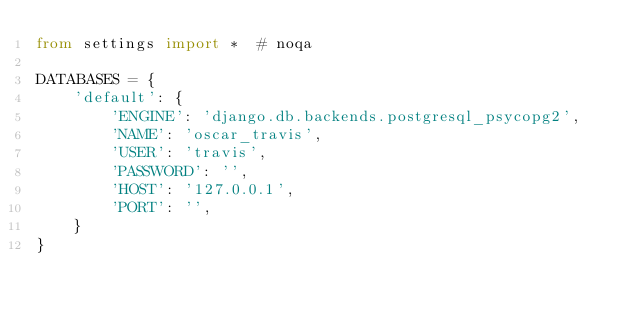<code> <loc_0><loc_0><loc_500><loc_500><_Python_>from settings import *  # noqa

DATABASES = {
    'default': {
        'ENGINE': 'django.db.backends.postgresql_psycopg2',
        'NAME': 'oscar_travis',
        'USER': 'travis',
        'PASSWORD': '',
        'HOST': '127.0.0.1',
        'PORT': '',
    }
}
</code> 